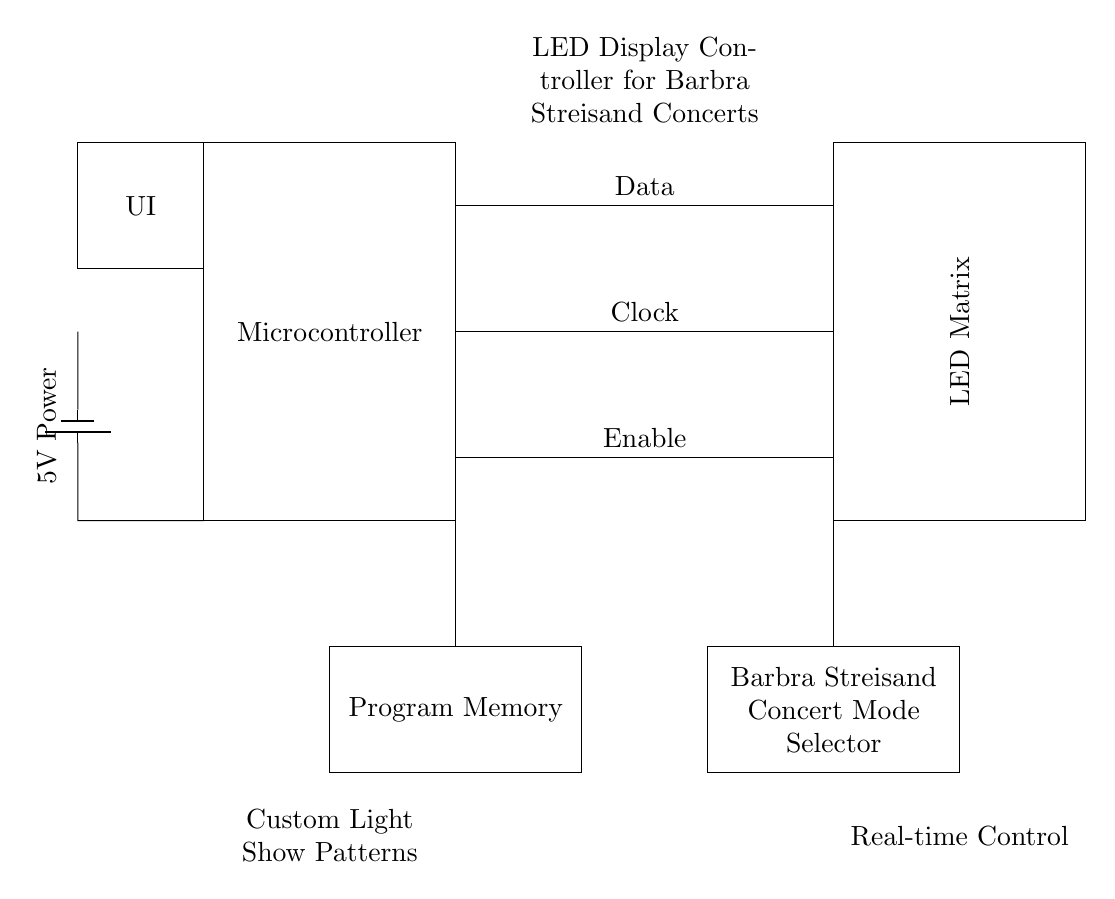What is the main component in this circuit? The main component shown in the circuit diagram is the Microcontroller, which is responsible for controlling the entire LED display system.
Answer: Microcontroller What provides power to the circuit? The power supply is indicated as a battery, which supplies 5 volts to the entire circuit, ensuring all components receive the necessary power to operate.
Answer: 5V Power How many connections are made from the microcontroller to the LED matrix? There are three connections made from the microcontroller to the LED matrix, labeled Data, Clock, and Enable. These connections are essential for communication and control of the LED display.
Answer: Three What is the function of the Program Memory in this circuit? The Program Memory stores the customized light show patterns that will be displayed on the LED matrix, allowing the microcontroller to access these patterns during operation.
Answer: Custom Light Show Patterns What is the purpose of the Barbra Streisand Concert Mode Selector? The Barbra Streisand Concert Mode Selector allows users to choose specific light show modes tailored for viewing Barbra Streisand concerts, enhancing the overall experience with suitable lighting.
Answer: Real-time Control 